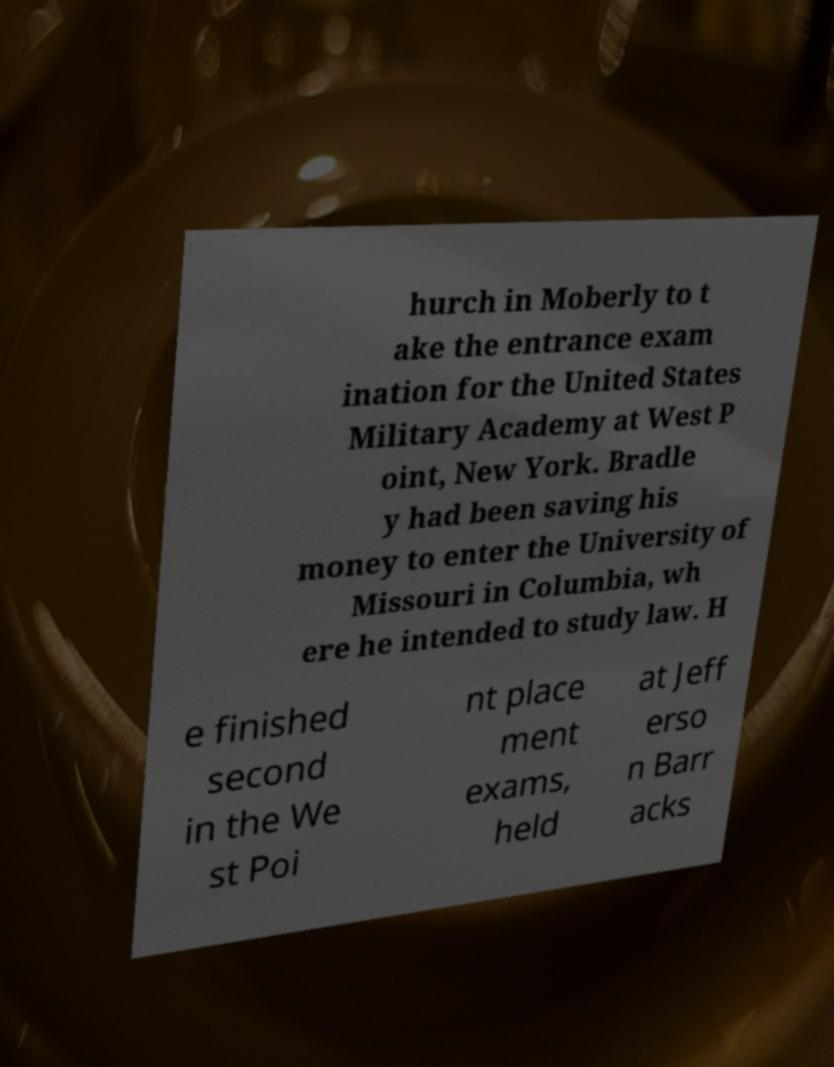Can you read and provide the text displayed in the image?This photo seems to have some interesting text. Can you extract and type it out for me? hurch in Moberly to t ake the entrance exam ination for the United States Military Academy at West P oint, New York. Bradle y had been saving his money to enter the University of Missouri in Columbia, wh ere he intended to study law. H e finished second in the We st Poi nt place ment exams, held at Jeff erso n Barr acks 